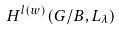<formula> <loc_0><loc_0><loc_500><loc_500>H ^ { l ( w ) } ( G / B , L _ { \lambda } )</formula> 